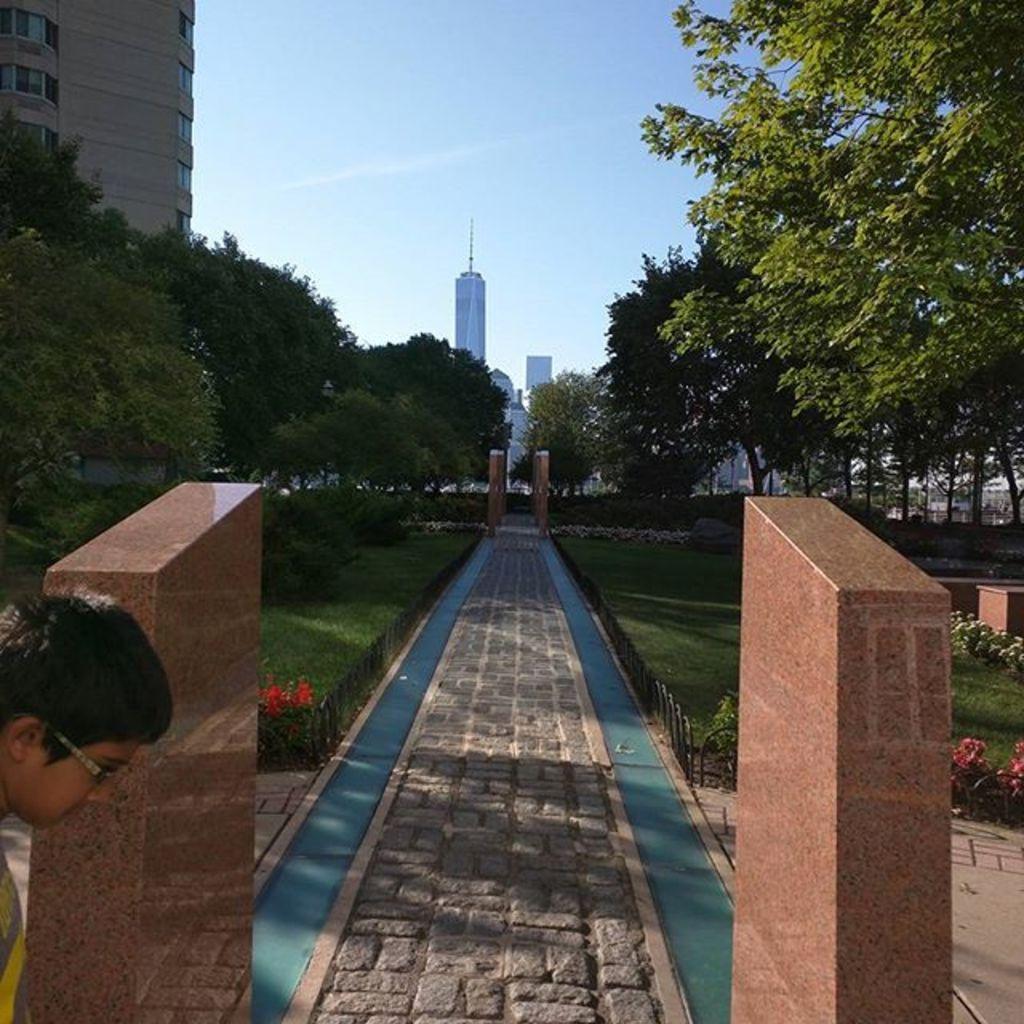In one or two sentences, can you explain what this image depicts? In this image we can see concrete walkway, beside that we can see water and pillars, we can see one boy, beside that we can see grass, flower plants, plants and trees. And we can see the buildings in the background, at the top we can see the sky with clouds. 